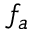<formula> <loc_0><loc_0><loc_500><loc_500>f _ { a }</formula> 